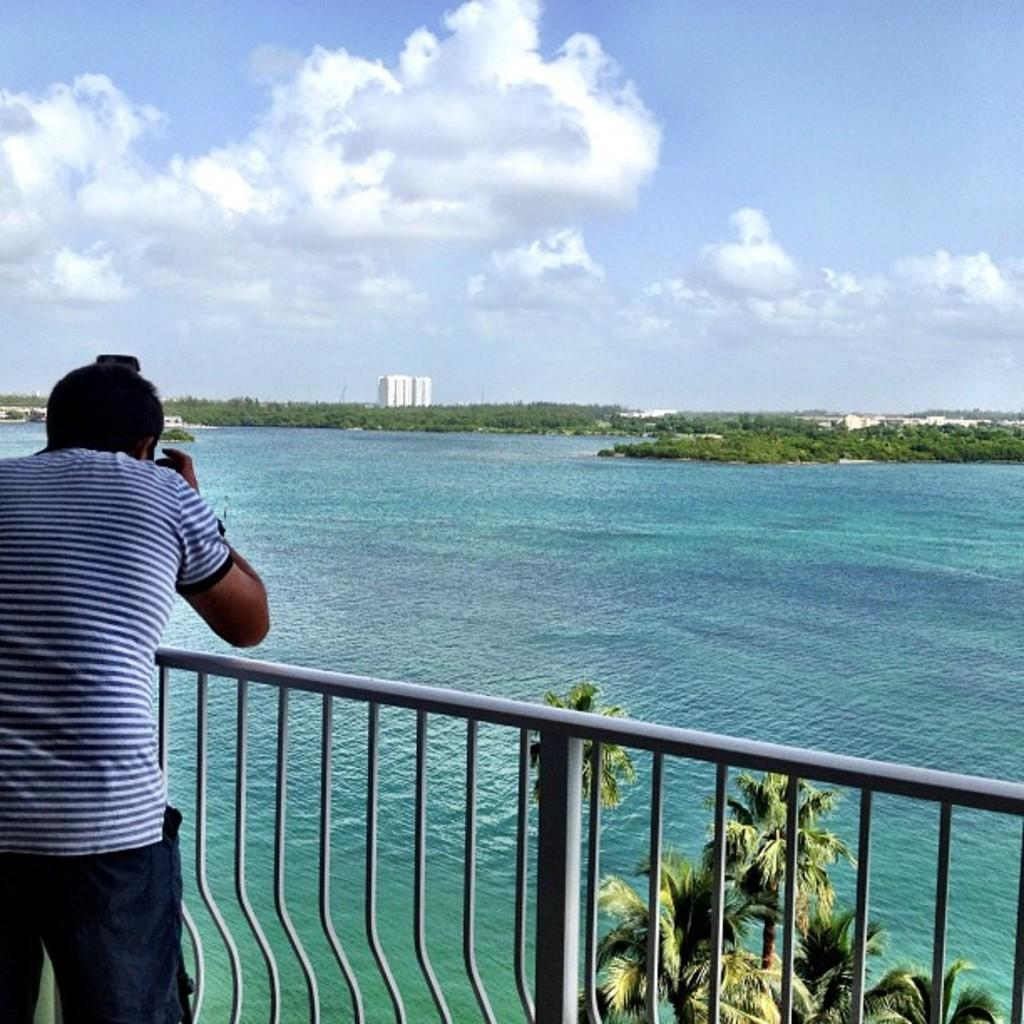What is the man in the picture doing? The man is taking a picture. What is the man wearing? The man is wearing a blue t-shirt. What is the subject of the man's picture? The subject of the man's picture is a nature scene. What can be seen in the nature scene? There is a lake with water and trees in the image. What else can be seen in the image? There is a white building in the image. Reasoning: Let'g: Let's think step by step in order to produce the conversation. We start by identifying the main subject in the image, which is the man taking a picture. Then, we describe what the man is wearing and the subject of his picture. Next, we expand the conversation to include other elements of the nature scene, such as the lake, trees, and the white building. Each question is designed to elicit a specific detail about the image that is known from the provided facts. Absurd Question/Answer: How does the growth of the earth affect the man's picture? The growth of the earth is not visible or mentioned in the image, so it cannot affect the man's picture. What type of shock can be seen on the man's face while taking the picture? A: There is no indication of shock on the man's face in the image, and his facial expression is not described. 